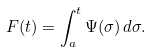<formula> <loc_0><loc_0><loc_500><loc_500>F ( t ) = \int _ { a } ^ { t } \Psi ( \sigma ) \, d \sigma .</formula> 